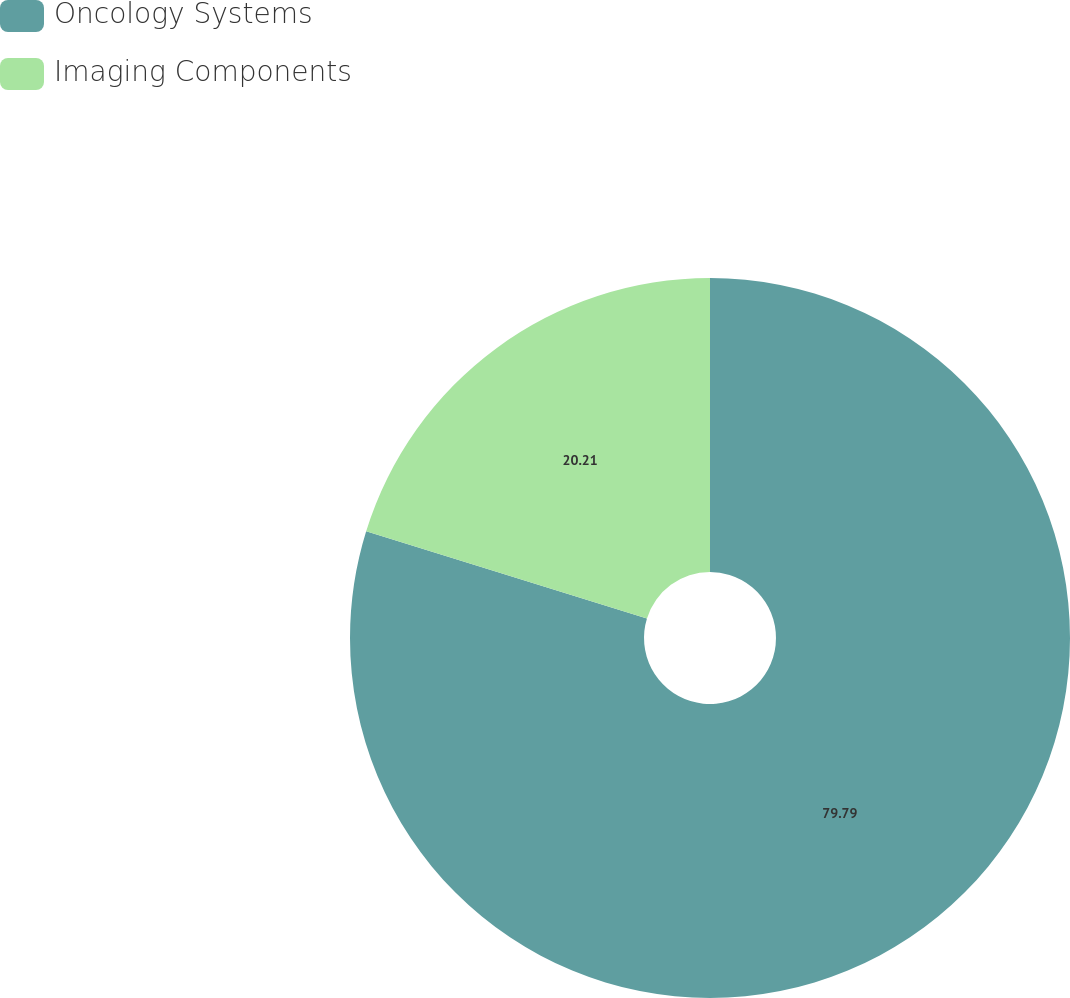Convert chart to OTSL. <chart><loc_0><loc_0><loc_500><loc_500><pie_chart><fcel>Oncology Systems<fcel>Imaging Components<nl><fcel>79.79%<fcel>20.21%<nl></chart> 